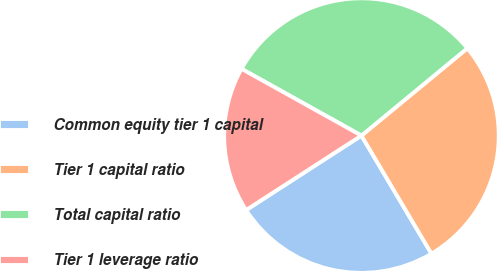Convert chart. <chart><loc_0><loc_0><loc_500><loc_500><pie_chart><fcel>Common equity tier 1 capital<fcel>Tier 1 capital ratio<fcel>Total capital ratio<fcel>Tier 1 leverage ratio<nl><fcel>24.39%<fcel>27.46%<fcel>30.94%<fcel>17.21%<nl></chart> 